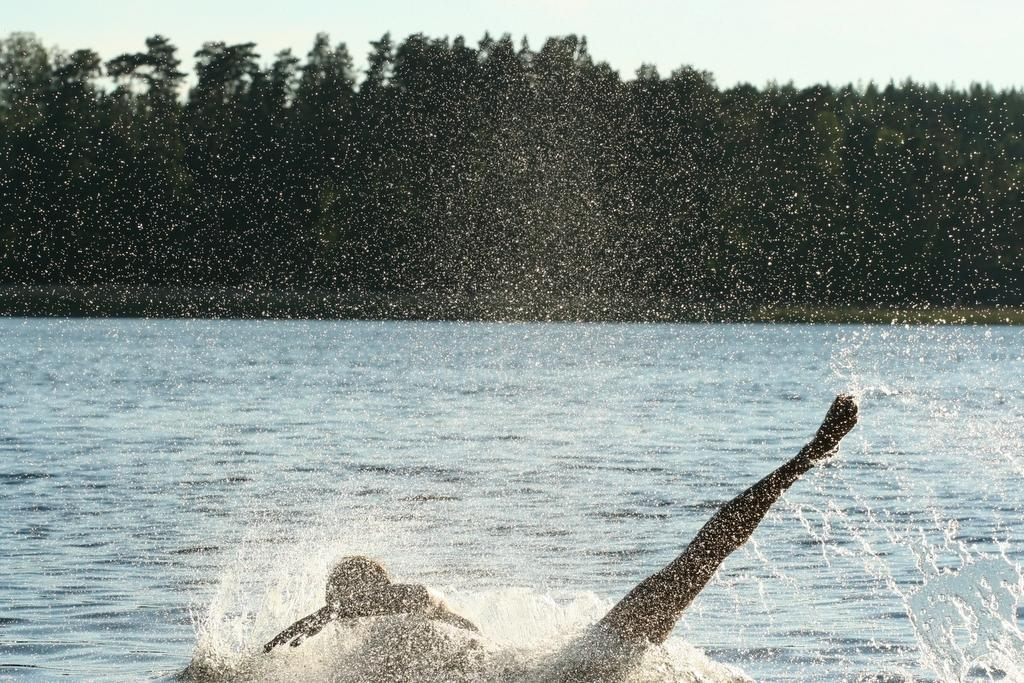What is the person in the image doing? There is a person swimming in the image. What can be seen in the background of the image? There are trees and the sky visible in the background of the image. What type of engine can be seen on the shelf in the image? There is no engine or shelf present in the image. How many girls are visible in the image? There are no girls present in the image; it features a person swimming. 